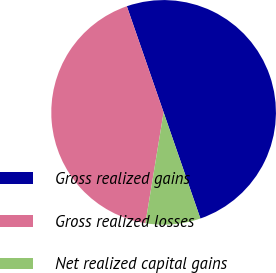Convert chart. <chart><loc_0><loc_0><loc_500><loc_500><pie_chart><fcel>Gross realized gains<fcel>Gross realized losses<fcel>Net realized capital gains<nl><fcel>50.0%<fcel>42.1%<fcel>7.9%<nl></chart> 